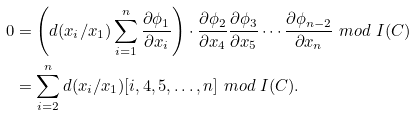Convert formula to latex. <formula><loc_0><loc_0><loc_500><loc_500>0 & = \left ( d ( x _ { i } / x _ { 1 } ) \sum _ { i = 1 } ^ { n } \frac { \partial \phi _ { 1 } } { \partial x _ { i } } \right ) \cdot \frac { \partial \phi _ { 2 } } { \partial x _ { 4 } } \frac { \partial \phi _ { 3 } } { \partial x _ { 5 } } \cdots \frac { \partial \phi _ { n - 2 } } { \partial x _ { n } } \ m o d \ I ( C ) \\ & = \sum _ { i = 2 } ^ { n } d ( x _ { i } / x _ { 1 } ) [ i , 4 , 5 , \dots , n ] \ m o d \ I ( C ) .</formula> 